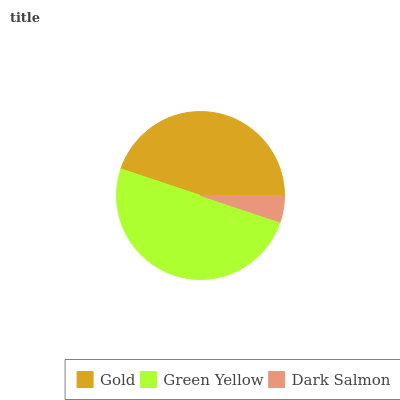Is Dark Salmon the minimum?
Answer yes or no. Yes. Is Green Yellow the maximum?
Answer yes or no. Yes. Is Green Yellow the minimum?
Answer yes or no. No. Is Dark Salmon the maximum?
Answer yes or no. No. Is Green Yellow greater than Dark Salmon?
Answer yes or no. Yes. Is Dark Salmon less than Green Yellow?
Answer yes or no. Yes. Is Dark Salmon greater than Green Yellow?
Answer yes or no. No. Is Green Yellow less than Dark Salmon?
Answer yes or no. No. Is Gold the high median?
Answer yes or no. Yes. Is Gold the low median?
Answer yes or no. Yes. Is Green Yellow the high median?
Answer yes or no. No. Is Green Yellow the low median?
Answer yes or no. No. 